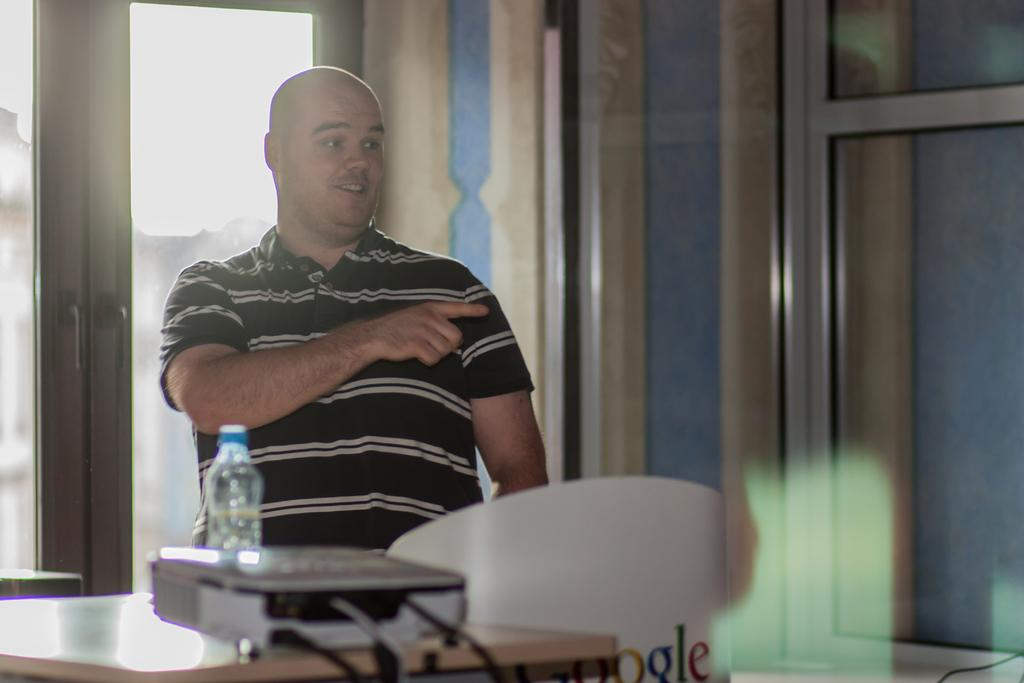What can be seen in the image? There is a person in the image. What is the person wearing? The person is wearing a black shirt. What is the person doing in the image? The person is standing. What objects are in front of the person? There is a projector and a water bottle in front of the person. What is visible behind the person? There is a door behind the person. What type of smile can be seen on the person's face in the image? There is no indication of the person's facial expression in the image, so it cannot be determined if they are smiling or not. 